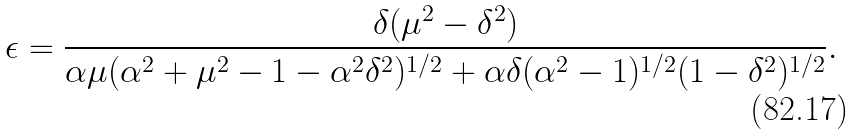Convert formula to latex. <formula><loc_0><loc_0><loc_500><loc_500>\epsilon = \frac { \delta ( \mu ^ { 2 } - \delta ^ { 2 } ) } { \alpha \mu ( \alpha ^ { 2 } + \mu ^ { 2 } - 1 - \alpha ^ { 2 } \delta ^ { 2 } ) ^ { 1 / 2 } + \alpha \delta ( \alpha ^ { 2 } - 1 ) ^ { 1 / 2 } ( 1 - \delta ^ { 2 } ) ^ { 1 / 2 } } .</formula> 